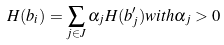Convert formula to latex. <formula><loc_0><loc_0><loc_500><loc_500>H ( b _ { i } ) = \sum _ { j \in J } \alpha _ { j } H ( b ^ { \prime } _ { j } ) w i t h \alpha _ { j } > 0</formula> 